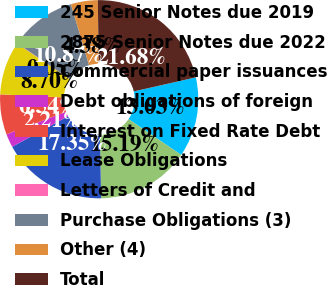Convert chart. <chart><loc_0><loc_0><loc_500><loc_500><pie_chart><fcel>245 Senior Notes due 2019<fcel>2875 Senior Notes due 2022<fcel>Commercial paper issuances<fcel>Debt obligations of foreign<fcel>Interest on Fixed Rate Debt<fcel>Lease Obligations<fcel>Letters of Credit and<fcel>Purchase Obligations (3)<fcel>Other (4)<fcel>Total<nl><fcel>13.03%<fcel>15.19%<fcel>17.35%<fcel>2.21%<fcel>6.54%<fcel>8.7%<fcel>0.05%<fcel>10.87%<fcel>4.38%<fcel>21.68%<nl></chart> 